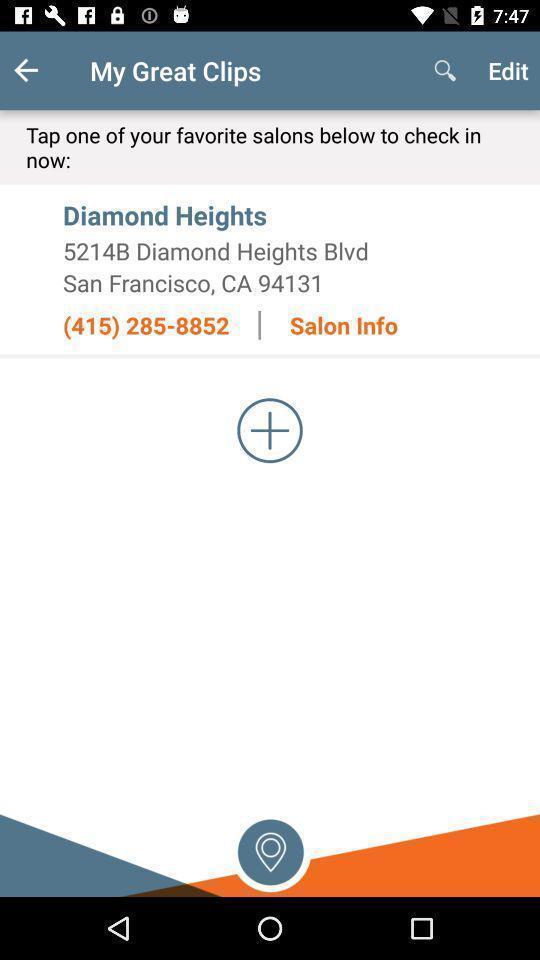Explain what's happening in this screen capture. Screen displaying location information and a search icon. 